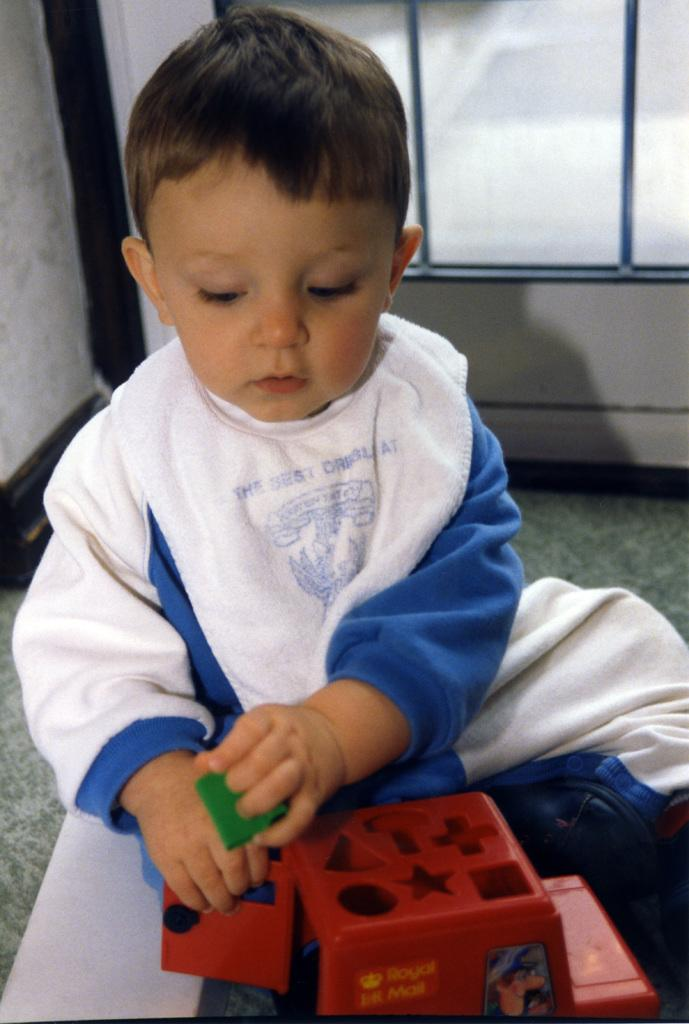Who is in the image? There is a boy in the image. What is the boy doing in the image? The boy is sitting on the floor. What is the boy holding in the image? The boy is holding a toy. Can you describe the background of the image? There is a wall and a glass window in the background of the image. What type of whistle can be heard coming from the cows in the image? There are no cows present in the image, so it's not possible to determine if any whistles can be heard. 